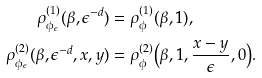Convert formula to latex. <formula><loc_0><loc_0><loc_500><loc_500>\rho ^ { ( 1 ) } _ { \phi _ { \epsilon } } ( \beta , \epsilon ^ { - d } ) & = \rho ^ { ( 1 ) } _ { \phi } ( \beta , 1 ) , \\ \rho ^ { ( 2 ) } _ { \phi _ { \epsilon } } ( \beta , \epsilon ^ { - d } , x , y ) & = \rho ^ { ( 2 ) } _ { \phi } \Big { ( } \beta , 1 , \frac { x - y } { \epsilon } , 0 \Big { ) } .</formula> 